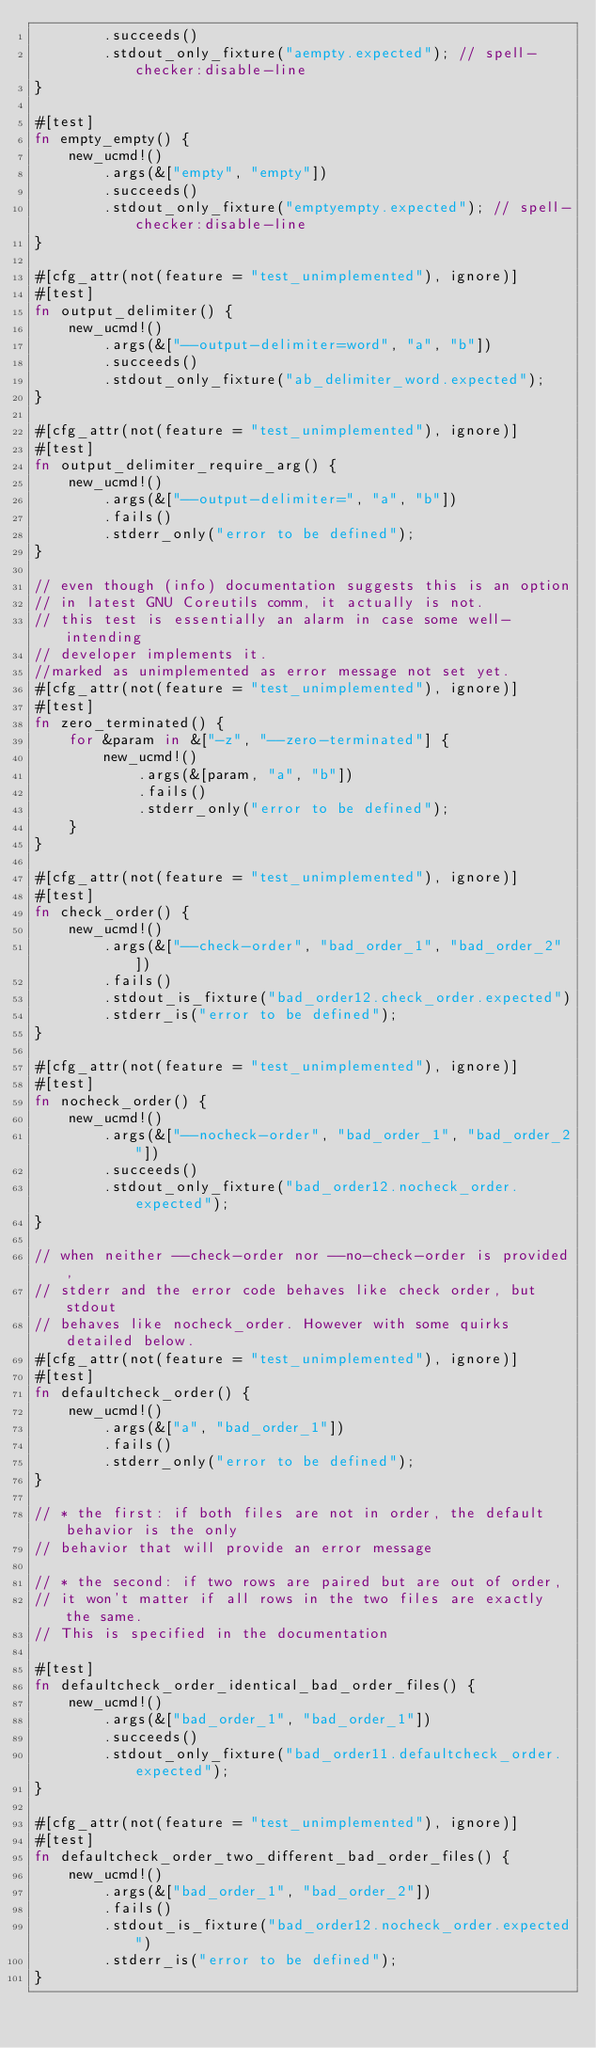<code> <loc_0><loc_0><loc_500><loc_500><_Rust_>        .succeeds()
        .stdout_only_fixture("aempty.expected"); // spell-checker:disable-line
}

#[test]
fn empty_empty() {
    new_ucmd!()
        .args(&["empty", "empty"])
        .succeeds()
        .stdout_only_fixture("emptyempty.expected"); // spell-checker:disable-line
}

#[cfg_attr(not(feature = "test_unimplemented"), ignore)]
#[test]
fn output_delimiter() {
    new_ucmd!()
        .args(&["--output-delimiter=word", "a", "b"])
        .succeeds()
        .stdout_only_fixture("ab_delimiter_word.expected");
}

#[cfg_attr(not(feature = "test_unimplemented"), ignore)]
#[test]
fn output_delimiter_require_arg() {
    new_ucmd!()
        .args(&["--output-delimiter=", "a", "b"])
        .fails()
        .stderr_only("error to be defined");
}

// even though (info) documentation suggests this is an option
// in latest GNU Coreutils comm, it actually is not.
// this test is essentially an alarm in case some well-intending
// developer implements it.
//marked as unimplemented as error message not set yet.
#[cfg_attr(not(feature = "test_unimplemented"), ignore)]
#[test]
fn zero_terminated() {
    for &param in &["-z", "--zero-terminated"] {
        new_ucmd!()
            .args(&[param, "a", "b"])
            .fails()
            .stderr_only("error to be defined");
    }
}

#[cfg_attr(not(feature = "test_unimplemented"), ignore)]
#[test]
fn check_order() {
    new_ucmd!()
        .args(&["--check-order", "bad_order_1", "bad_order_2"])
        .fails()
        .stdout_is_fixture("bad_order12.check_order.expected")
        .stderr_is("error to be defined");
}

#[cfg_attr(not(feature = "test_unimplemented"), ignore)]
#[test]
fn nocheck_order() {
    new_ucmd!()
        .args(&["--nocheck-order", "bad_order_1", "bad_order_2"])
        .succeeds()
        .stdout_only_fixture("bad_order12.nocheck_order.expected");
}

// when neither --check-order nor --no-check-order is provided,
// stderr and the error code behaves like check order, but stdout
// behaves like nocheck_order. However with some quirks detailed below.
#[cfg_attr(not(feature = "test_unimplemented"), ignore)]
#[test]
fn defaultcheck_order() {
    new_ucmd!()
        .args(&["a", "bad_order_1"])
        .fails()
        .stderr_only("error to be defined");
}

// * the first: if both files are not in order, the default behavior is the only
// behavior that will provide an error message

// * the second: if two rows are paired but are out of order,
// it won't matter if all rows in the two files are exactly the same.
// This is specified in the documentation

#[test]
fn defaultcheck_order_identical_bad_order_files() {
    new_ucmd!()
        .args(&["bad_order_1", "bad_order_1"])
        .succeeds()
        .stdout_only_fixture("bad_order11.defaultcheck_order.expected");
}

#[cfg_attr(not(feature = "test_unimplemented"), ignore)]
#[test]
fn defaultcheck_order_two_different_bad_order_files() {
    new_ucmd!()
        .args(&["bad_order_1", "bad_order_2"])
        .fails()
        .stdout_is_fixture("bad_order12.nocheck_order.expected")
        .stderr_is("error to be defined");
}
</code> 